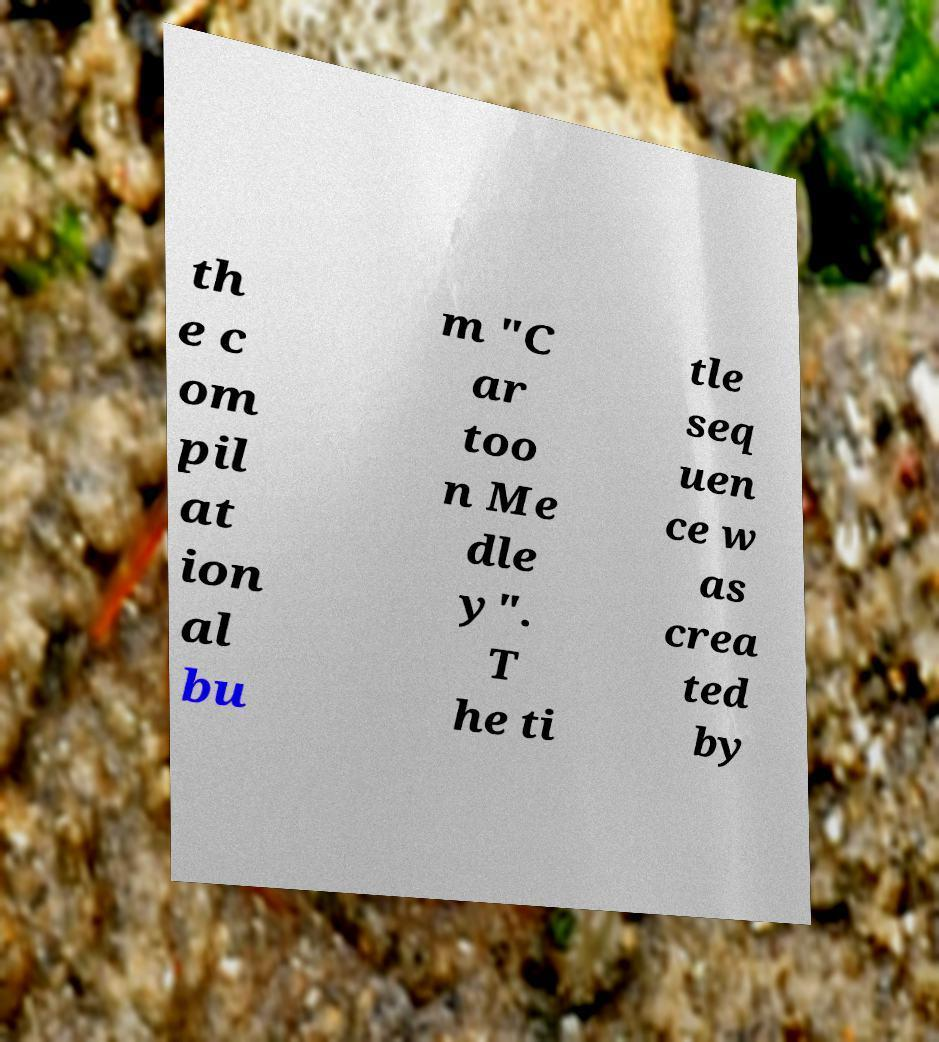There's text embedded in this image that I need extracted. Can you transcribe it verbatim? th e c om pil at ion al bu m "C ar too n Me dle y". T he ti tle seq uen ce w as crea ted by 